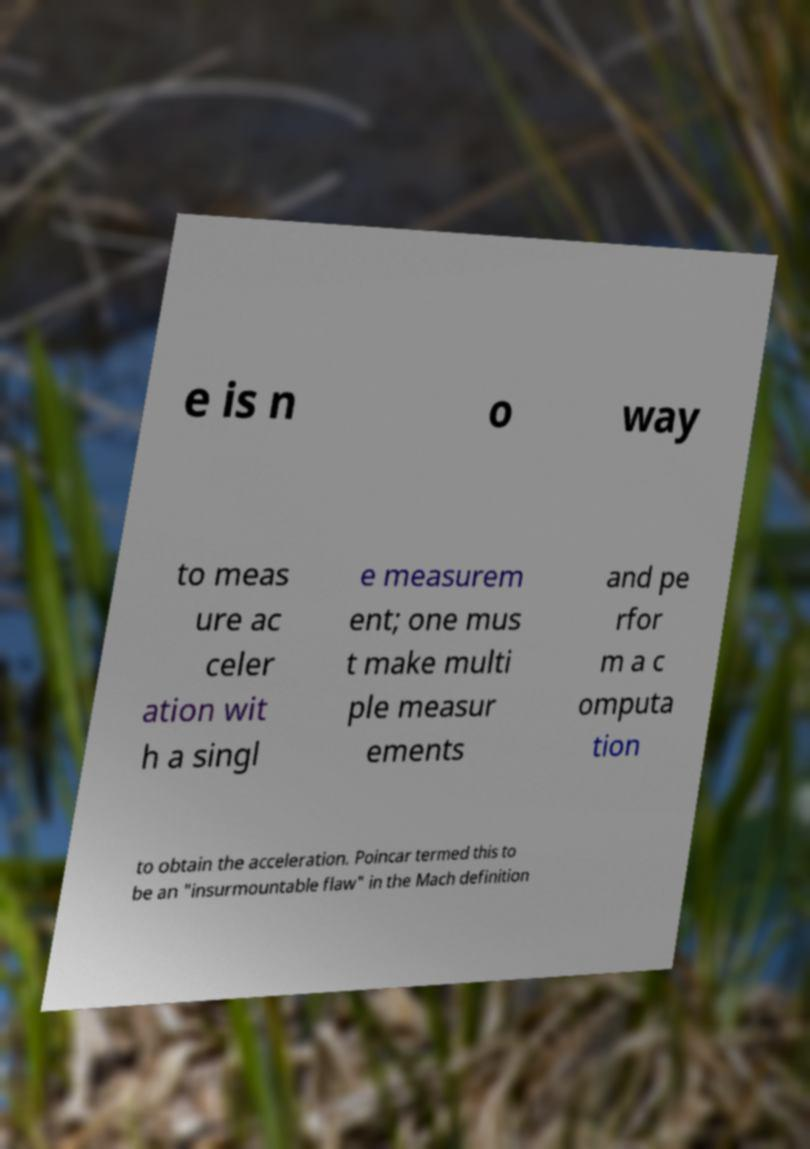What messages or text are displayed in this image? I need them in a readable, typed format. e is n o way to meas ure ac celer ation wit h a singl e measurem ent; one mus t make multi ple measur ements and pe rfor m a c omputa tion to obtain the acceleration. Poincar termed this to be an "insurmountable flaw" in the Mach definition 